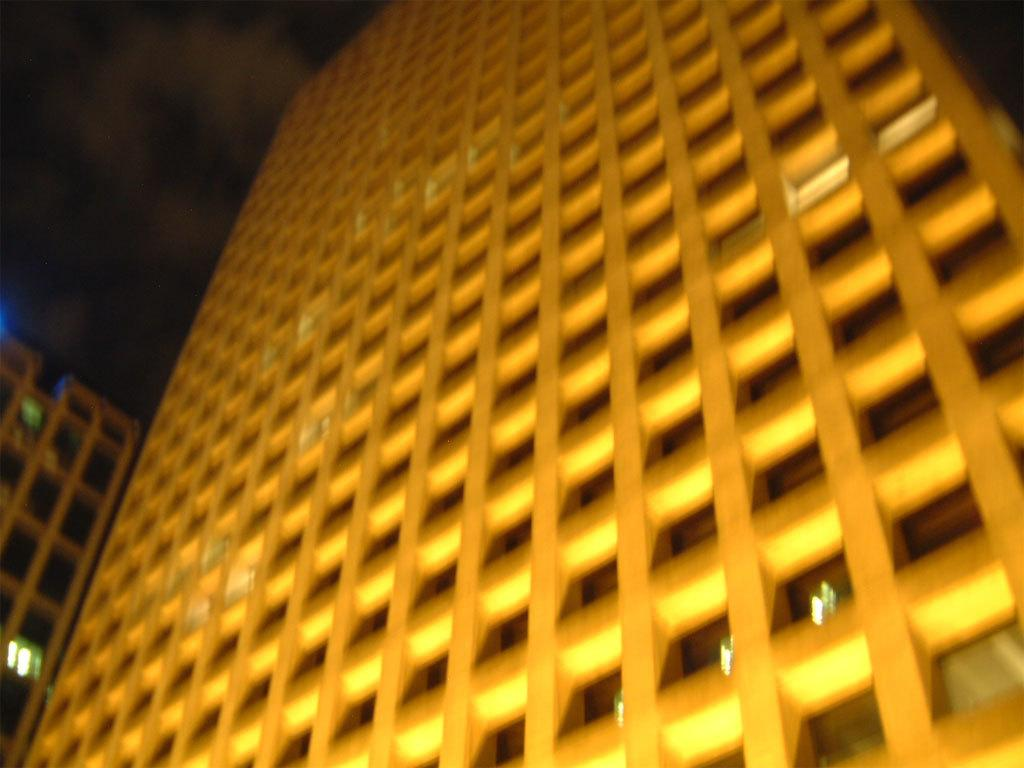What type of structures can be seen in the image? There are buildings in the image. What can be seen in the background of the image? There are clouds and the sky visible in the background of the image. What type of cork can be seen floating in the image? There is no cork present in the image; it features buildings and a sky with clouds. 